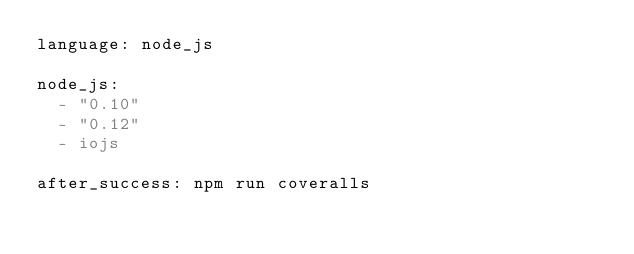Convert code to text. <code><loc_0><loc_0><loc_500><loc_500><_YAML_>language: node_js

node_js:
  - "0.10"
  - "0.12"
  - iojs

after_success: npm run coveralls
</code> 